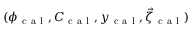Convert formula to latex. <formula><loc_0><loc_0><loc_500><loc_500>( \phi _ { c a l } , C _ { c a l } , y _ { c a l } , \vec { \zeta } _ { c a l } )</formula> 